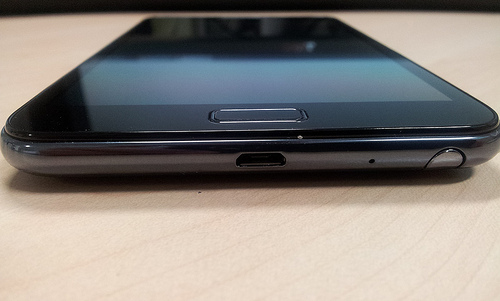<image>
Is the mobile above the table? No. The mobile is not positioned above the table. The vertical arrangement shows a different relationship. 